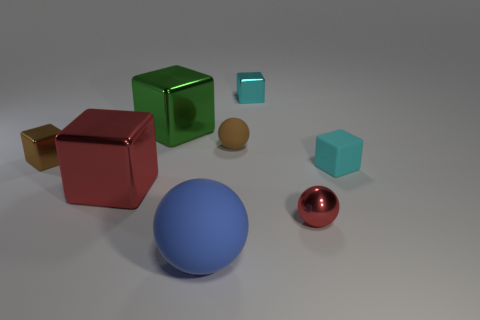Subtract 1 cubes. How many cubes are left? 4 Subtract all blue blocks. Subtract all purple balls. How many blocks are left? 5 Add 1 large blocks. How many objects exist? 9 Subtract all balls. How many objects are left? 5 Add 1 tiny red metal things. How many tiny red metal things are left? 2 Add 7 red things. How many red things exist? 9 Subtract 0 purple balls. How many objects are left? 8 Subtract all green metallic cubes. Subtract all tiny shiny things. How many objects are left? 4 